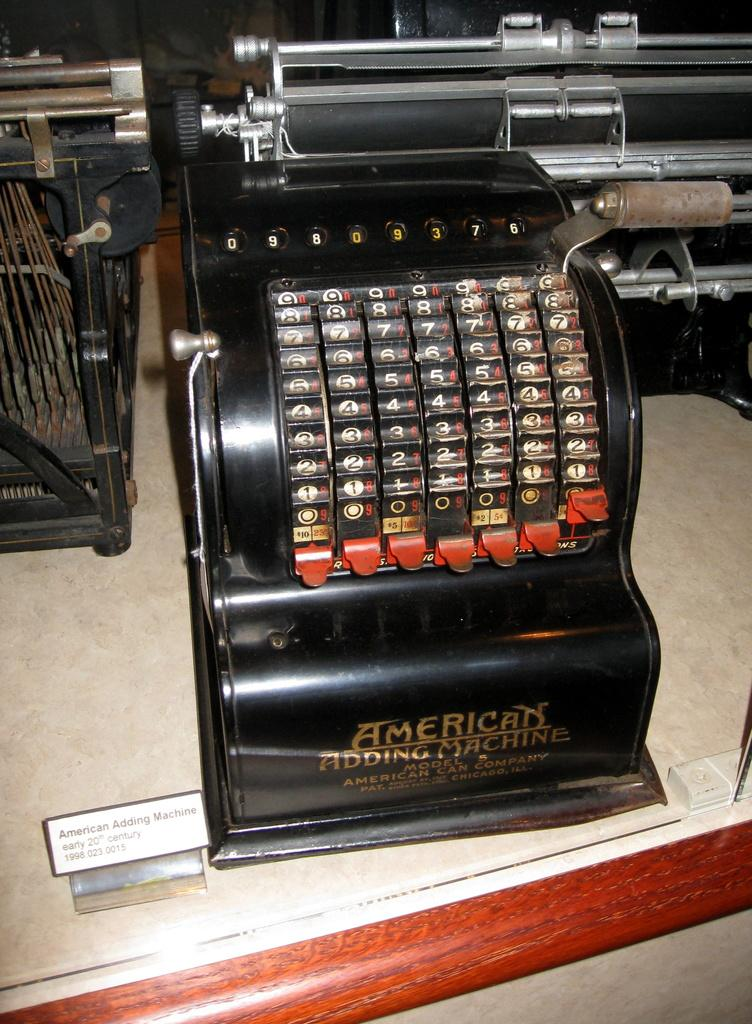<image>
Render a clear and concise summary of the photo. a typwriter with the words american adding machine on it 